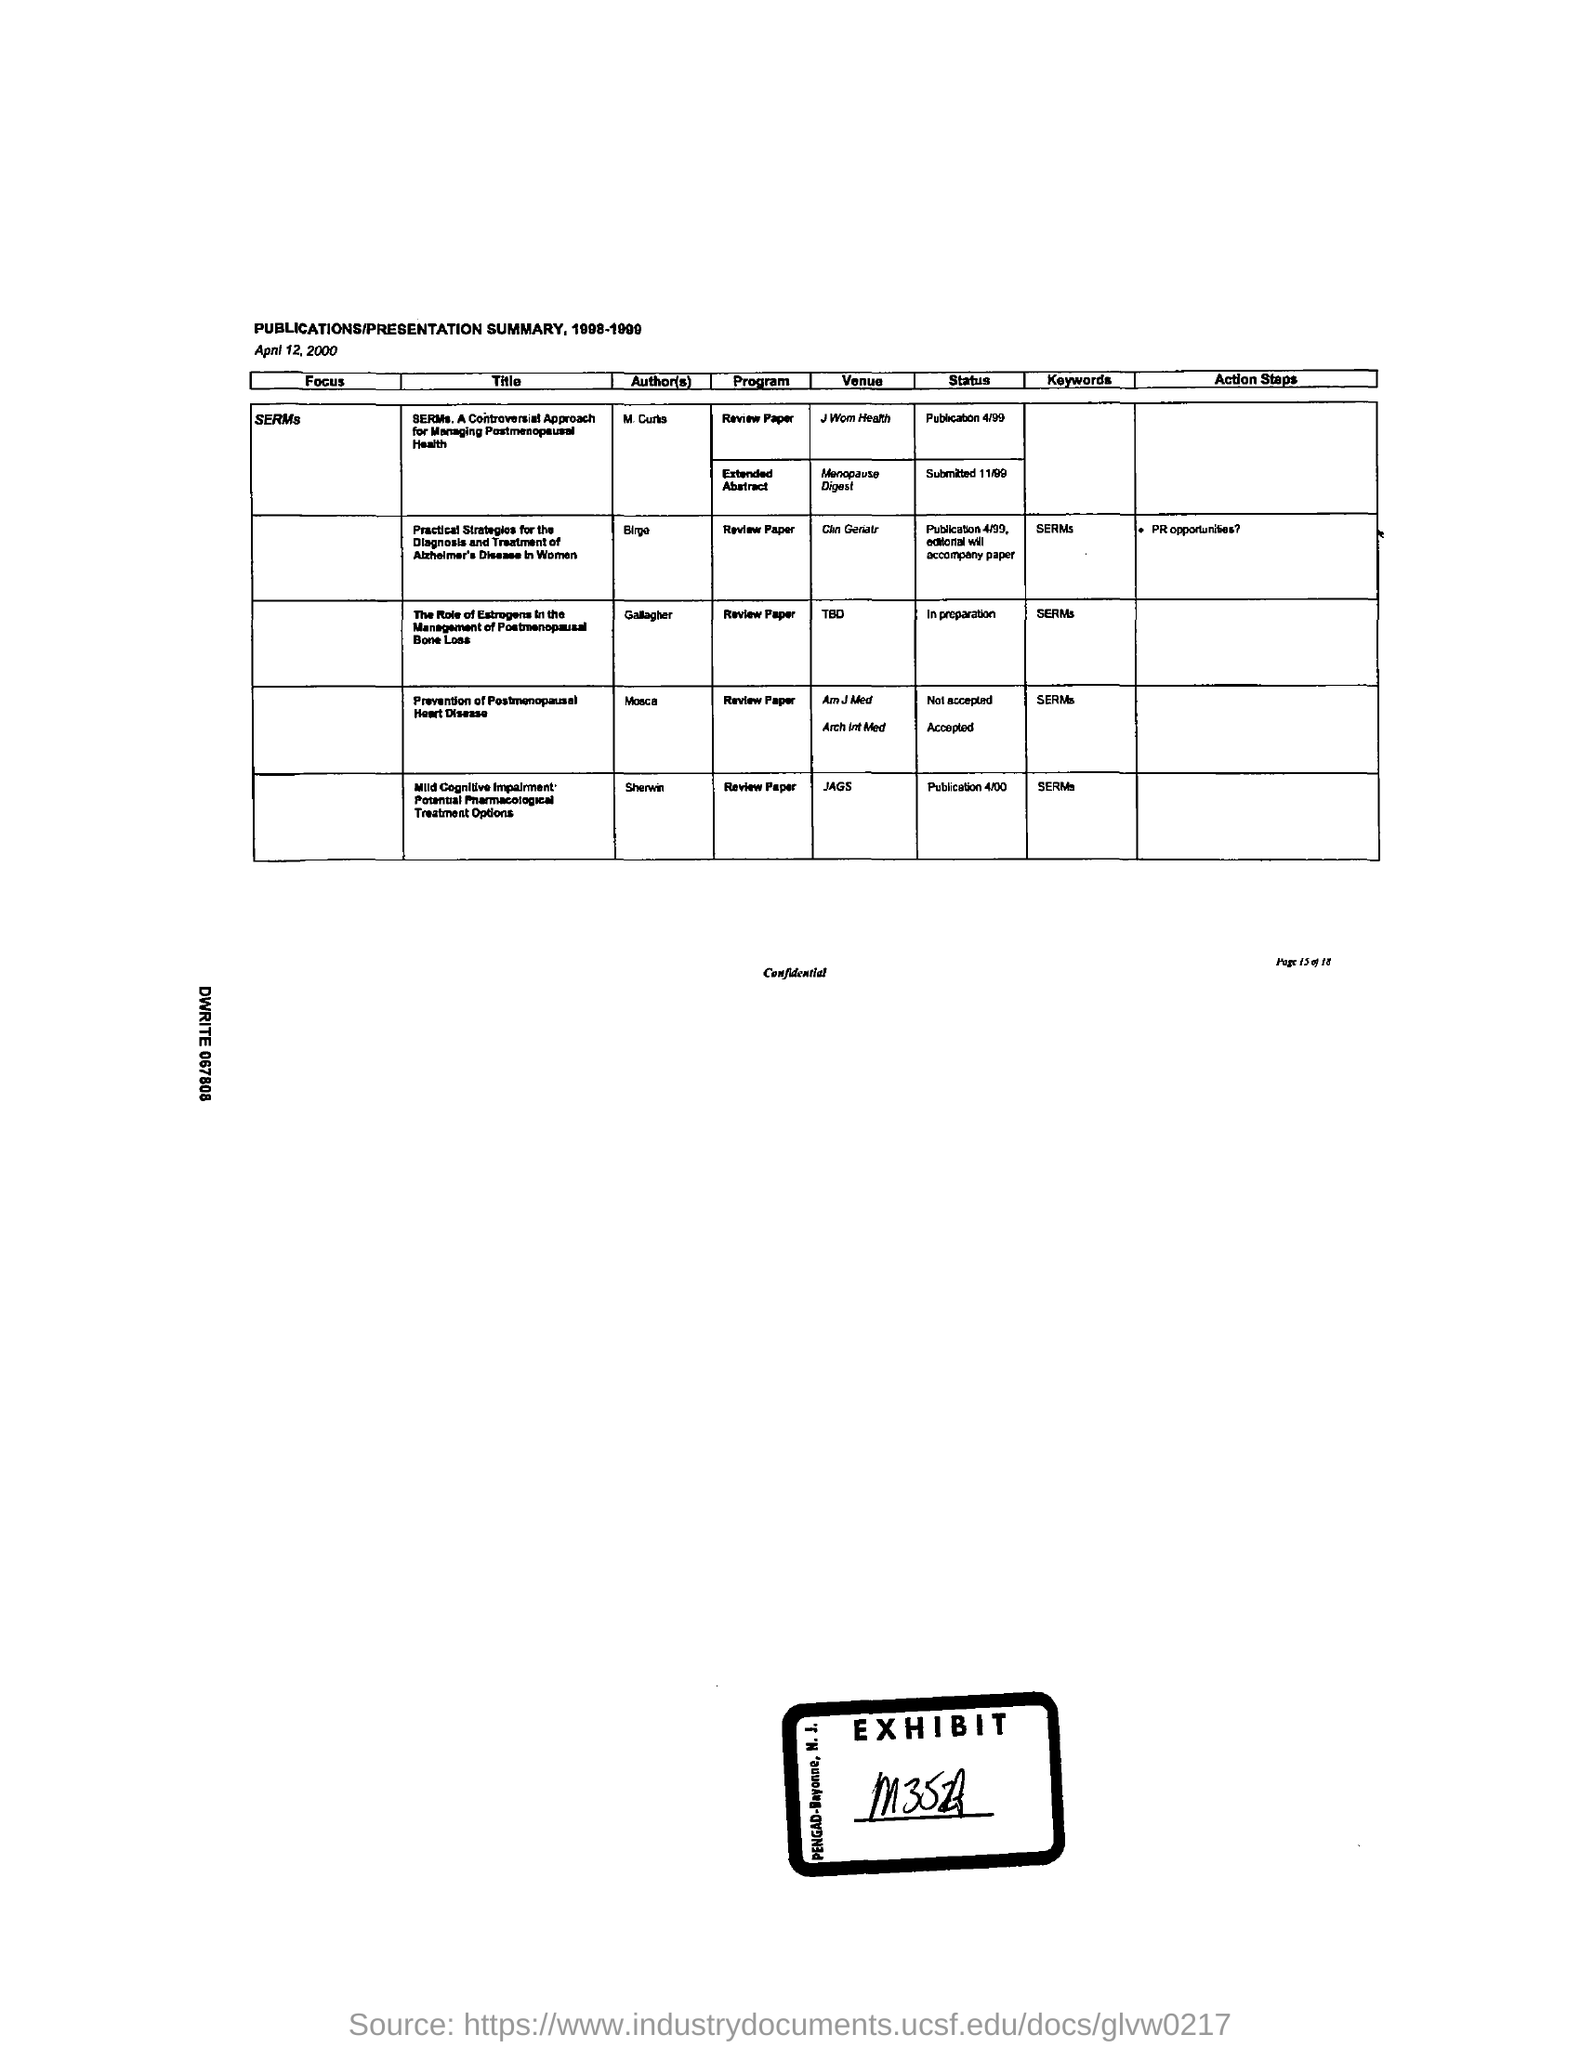Highlight a few significant elements in this photo. The prevention of postmenopausal heart disease is attributed to Mosca. 